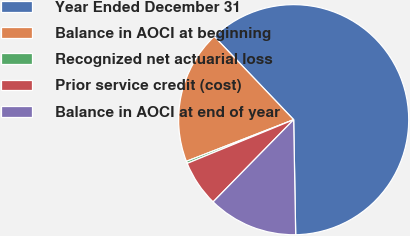Convert chart. <chart><loc_0><loc_0><loc_500><loc_500><pie_chart><fcel>Year Ended December 31<fcel>Balance in AOCI at beginning<fcel>Recognized net actuarial loss<fcel>Prior service credit (cost)<fcel>Balance in AOCI at end of year<nl><fcel>61.85%<fcel>18.77%<fcel>0.31%<fcel>6.46%<fcel>12.62%<nl></chart> 